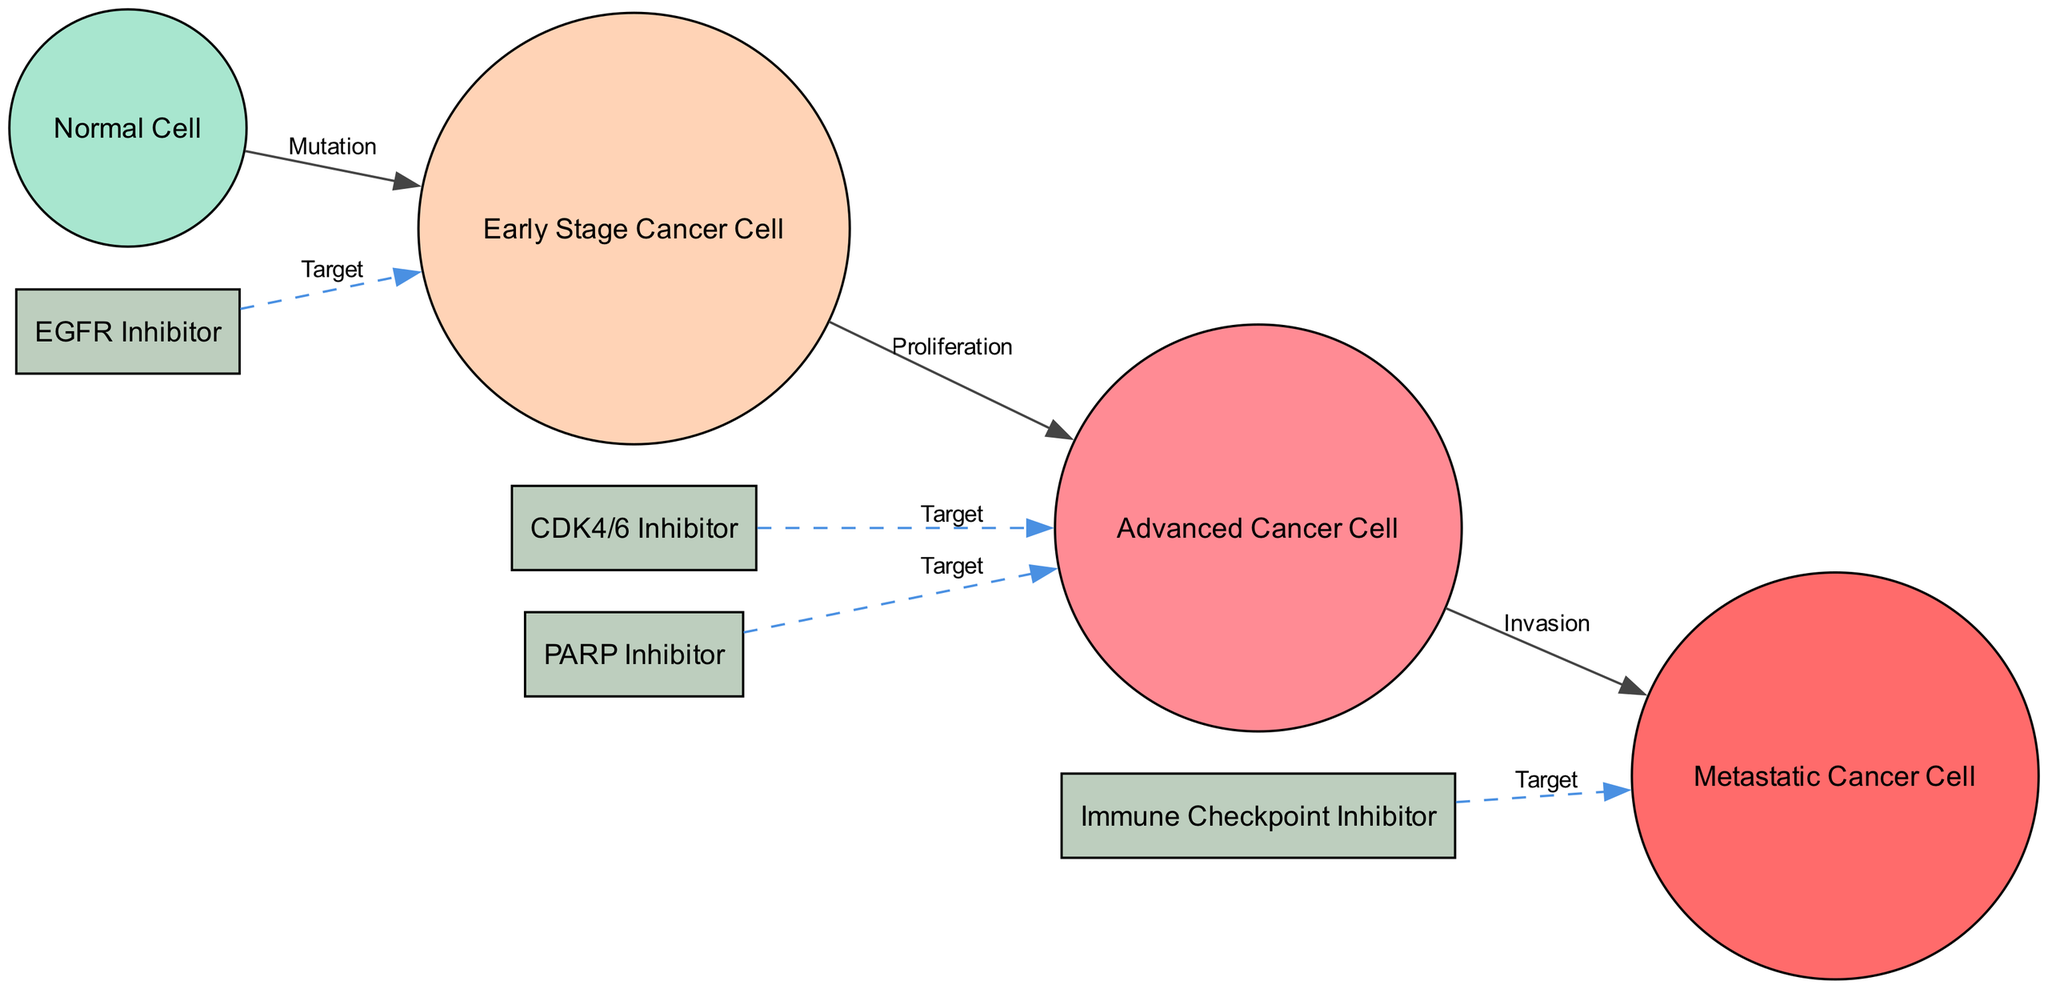What is the total number of nodes in the diagram? The diagram has 8 nodes, as listed in the data under the "nodes" key.
Answer: 8 What is the relationship label between the Normal Cell and the Early Stage Cancer Cell? The relationship between these two nodes is labeled as "Mutation", which is indicated in the edges section of the data.
Answer: Mutation Which drug is targeting the Advanced Cancer Cell? The drugs targeting the Advanced Cancer Cell are labeled as "CDK4/6 Inhibitor" and "PARP Inhibitor", each connected by edges marked as "Target".
Answer: CDK4/6 Inhibitor, PARP Inhibitor How many types of cancer cells are represented in the diagram? The diagram represents three types of cancer cells: Early Stage Cancer Cell, Advanced Cancer Cell, and Metastatic Cancer Cell, detailed in the nodes section.
Answer: 3 What is the label for the edge connecting the Advanced Cancer Cell to Metastatic Cancer Cell? The edge connecting the Advanced Cancer Cell to the Metastatic Cancer Cell is labeled as "Invasion". This can be inferred from the edges section where the specific connection and its label are defined.
Answer: Invasion Which inhibitors target the Metastatic Cancer Cell? The only drug targeting the Metastatic Cancer Cell in the diagram is the "Immune Checkpoint Inhibitor", indicated by the connection labeled as "Target".
Answer: Immune Checkpoint Inhibitor How many edges are labeled as "Target"? There are four edges labeled as "Target" connecting specific drugs to their corresponding cancer cells. The count can be achieved by reviewing the edges section of the data.
Answer: 4 What color represents the Advanced Cancer Cell in the diagram? The Advanced Cancer Cell is represented in the color "#FF8B94" according to the color scheme defined for different cell types in the diagram.
Answer: #FF8B94 